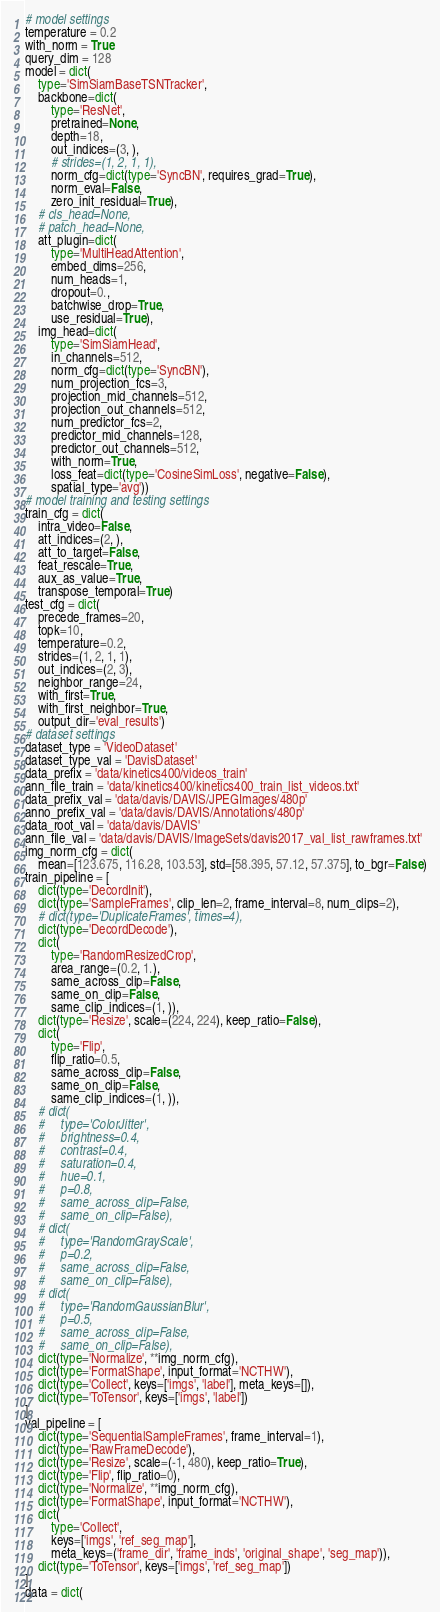Convert code to text. <code><loc_0><loc_0><loc_500><loc_500><_Python_># model settings
temperature = 0.2
with_norm = True
query_dim = 128
model = dict(
    type='SimSiamBaseTSNTracker',
    backbone=dict(
        type='ResNet',
        pretrained=None,
        depth=18,
        out_indices=(3, ),
        # strides=(1, 2, 1, 1),
        norm_cfg=dict(type='SyncBN', requires_grad=True),
        norm_eval=False,
        zero_init_residual=True),
    # cls_head=None,
    # patch_head=None,
    att_plugin=dict(
        type='MultiHeadAttention',
        embed_dims=256,
        num_heads=1,
        dropout=0.,
        batchwise_drop=True,
        use_residual=True),
    img_head=dict(
        type='SimSiamHead',
        in_channels=512,
        norm_cfg=dict(type='SyncBN'),
        num_projection_fcs=3,
        projection_mid_channels=512,
        projection_out_channels=512,
        num_predictor_fcs=2,
        predictor_mid_channels=128,
        predictor_out_channels=512,
        with_norm=True,
        loss_feat=dict(type='CosineSimLoss', negative=False),
        spatial_type='avg'))
# model training and testing settings
train_cfg = dict(
    intra_video=False,
    att_indices=(2, ),
    att_to_target=False,
    feat_rescale=True,
    aux_as_value=True,
    transpose_temporal=True)
test_cfg = dict(
    precede_frames=20,
    topk=10,
    temperature=0.2,
    strides=(1, 2, 1, 1),
    out_indices=(2, 3),
    neighbor_range=24,
    with_first=True,
    with_first_neighbor=True,
    output_dir='eval_results')
# dataset settings
dataset_type = 'VideoDataset'
dataset_type_val = 'DavisDataset'
data_prefix = 'data/kinetics400/videos_train'
ann_file_train = 'data/kinetics400/kinetics400_train_list_videos.txt'
data_prefix_val = 'data/davis/DAVIS/JPEGImages/480p'
anno_prefix_val = 'data/davis/DAVIS/Annotations/480p'
data_root_val = 'data/davis/DAVIS'
ann_file_val = 'data/davis/DAVIS/ImageSets/davis2017_val_list_rawframes.txt'
img_norm_cfg = dict(
    mean=[123.675, 116.28, 103.53], std=[58.395, 57.12, 57.375], to_bgr=False)
train_pipeline = [
    dict(type='DecordInit'),
    dict(type='SampleFrames', clip_len=2, frame_interval=8, num_clips=2),
    # dict(type='DuplicateFrames', times=4),
    dict(type='DecordDecode'),
    dict(
        type='RandomResizedCrop',
        area_range=(0.2, 1.),
        same_across_clip=False,
        same_on_clip=False,
        same_clip_indices=(1, )),
    dict(type='Resize', scale=(224, 224), keep_ratio=False),
    dict(
        type='Flip',
        flip_ratio=0.5,
        same_across_clip=False,
        same_on_clip=False,
        same_clip_indices=(1, )),
    # dict(
    #     type='ColorJitter',
    #     brightness=0.4,
    #     contrast=0.4,
    #     saturation=0.4,
    #     hue=0.1,
    #     p=0.8,
    #     same_across_clip=False,
    #     same_on_clip=False),
    # dict(
    #     type='RandomGrayScale',
    #     p=0.2,
    #     same_across_clip=False,
    #     same_on_clip=False),
    # dict(
    #     type='RandomGaussianBlur',
    #     p=0.5,
    #     same_across_clip=False,
    #     same_on_clip=False),
    dict(type='Normalize', **img_norm_cfg),
    dict(type='FormatShape', input_format='NCTHW'),
    dict(type='Collect', keys=['imgs', 'label'], meta_keys=[]),
    dict(type='ToTensor', keys=['imgs', 'label'])
]
val_pipeline = [
    dict(type='SequentialSampleFrames', frame_interval=1),
    dict(type='RawFrameDecode'),
    dict(type='Resize', scale=(-1, 480), keep_ratio=True),
    dict(type='Flip', flip_ratio=0),
    dict(type='Normalize', **img_norm_cfg),
    dict(type='FormatShape', input_format='NCTHW'),
    dict(
        type='Collect',
        keys=['imgs', 'ref_seg_map'],
        meta_keys=('frame_dir', 'frame_inds', 'original_shape', 'seg_map')),
    dict(type='ToTensor', keys=['imgs', 'ref_seg_map'])
]
data = dict(</code> 